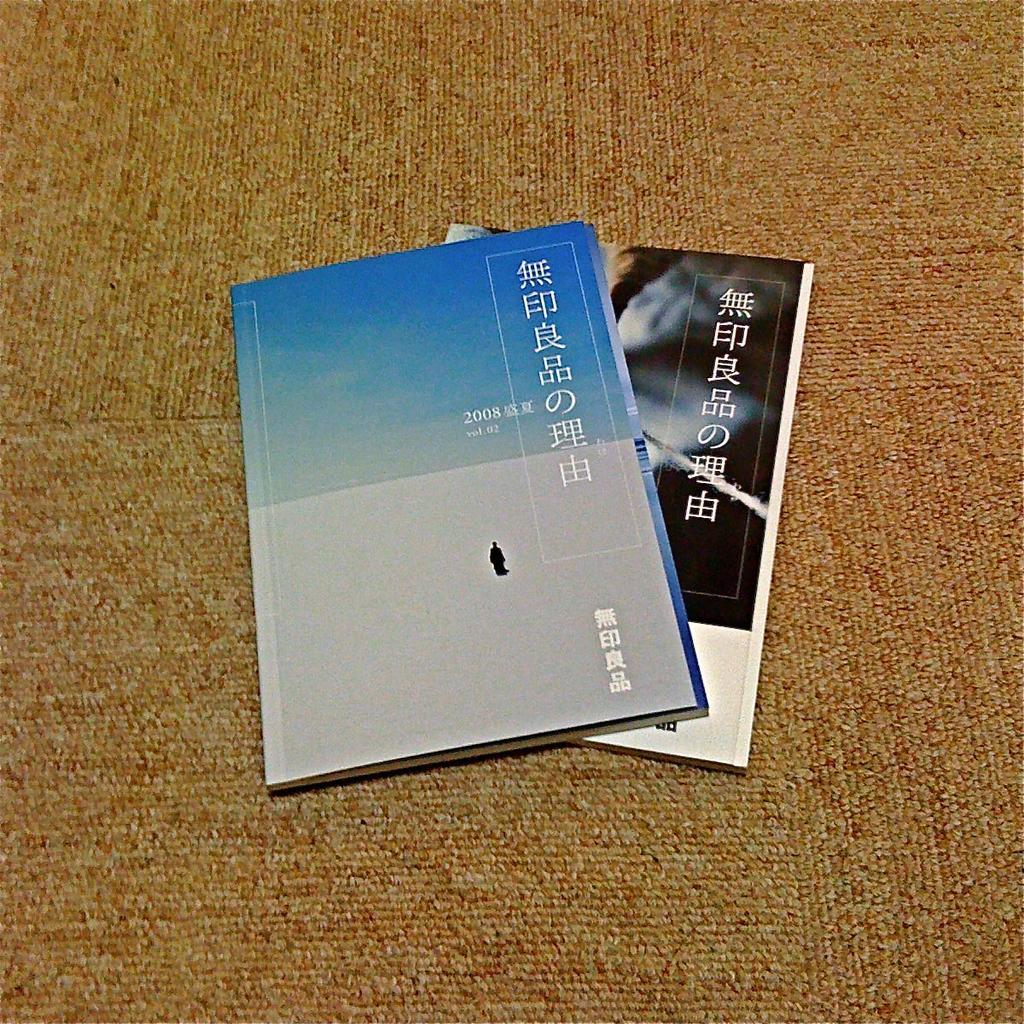Could you give a brief overview of what you see in this image? In this image there are books on a carpet. There is text on the books. 